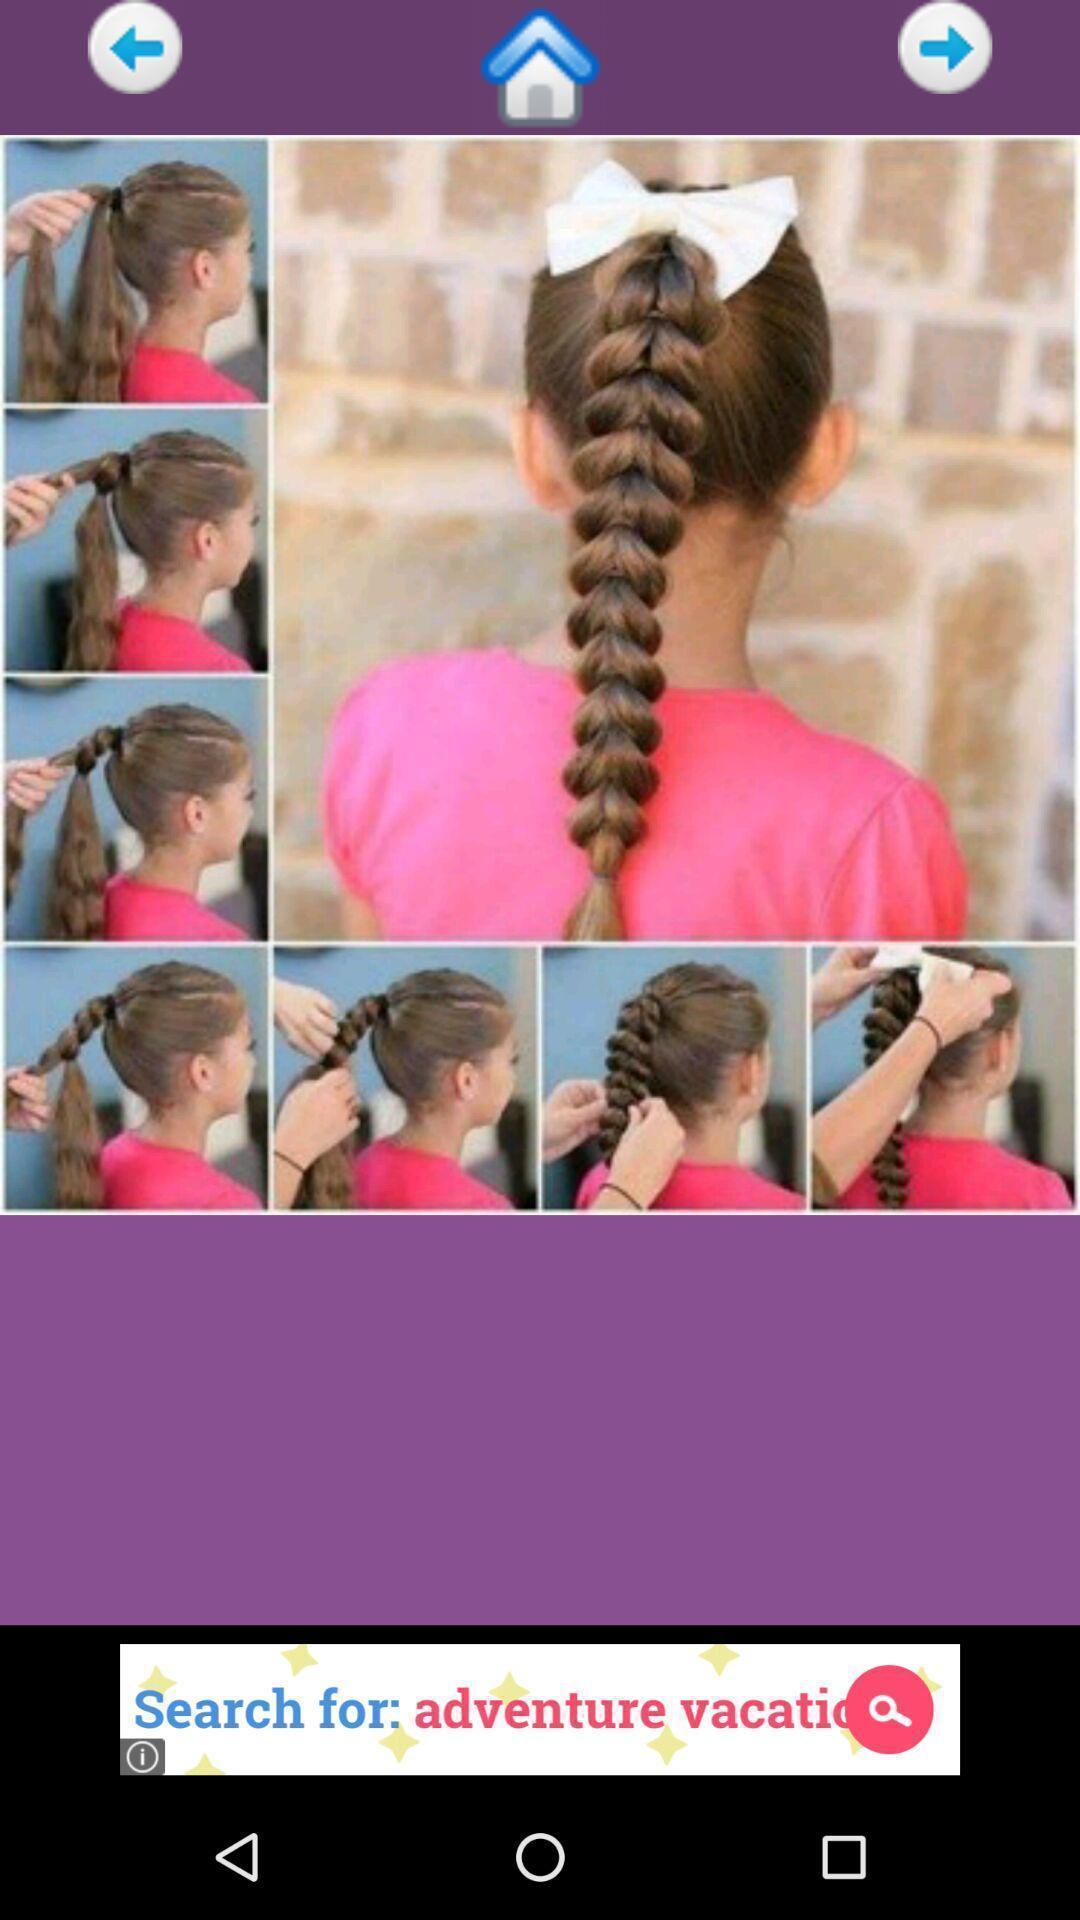Provide a detailed account of this screenshot. Page displaying steps of hairstyle on app. 